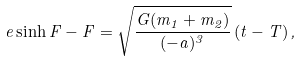<formula> <loc_0><loc_0><loc_500><loc_500>e \sinh F - F = \sqrt { \frac { G ( m _ { 1 } + m _ { 2 } ) } { ( - a ) ^ { 3 } } } \left ( t - T \right ) ,</formula> 